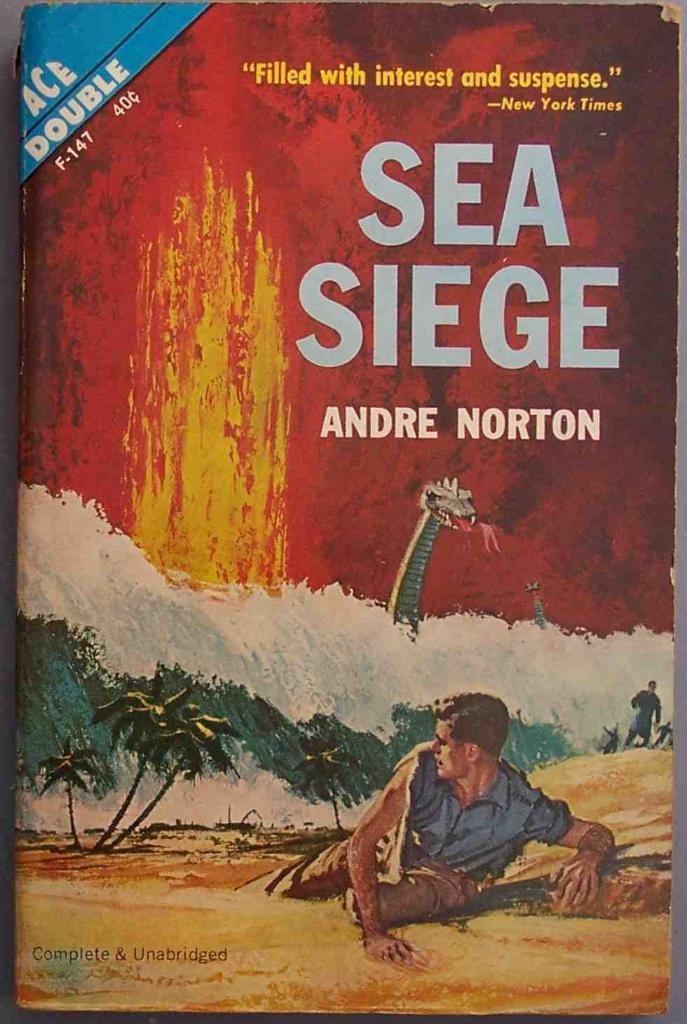<image>
Write a terse but informative summary of the picture. The cover of the book Sea Siege written by Andre Norton. 